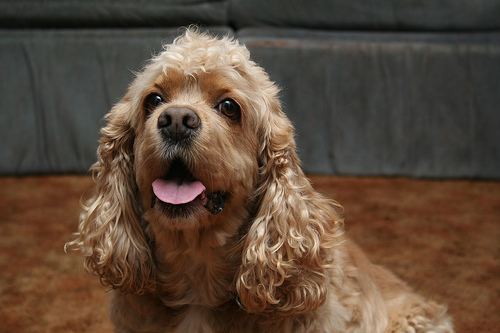<image>
Is there a dog on the sofa? No. The dog is not positioned on the sofa. They may be near each other, but the dog is not supported by or resting on top of the sofa. 